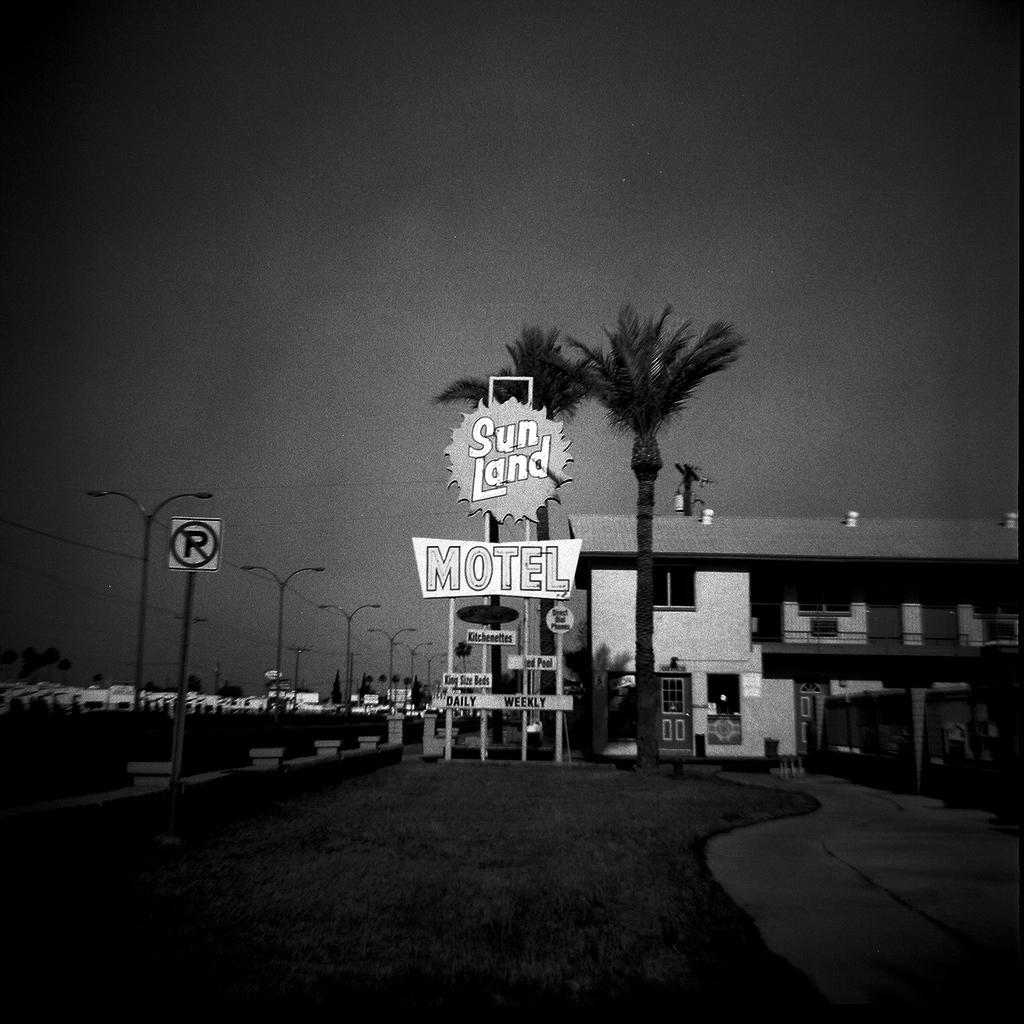What is the color scheme of the image? The image is black and white with borders. What type of structures can be seen in the image? There are buildings in the image. What other natural elements are present in the image? There are trees in the image. What type of man-made objects can be seen in the image? There are light poles in the image. What part of the natural environment is visible in the image? The sky is visible at the top of the image. What part of the man-made environment is visible in the image? The road is visible at the bottom of the image. What type of celery is being used to comfort the oven in the image? There is no celery or oven present in the image. 